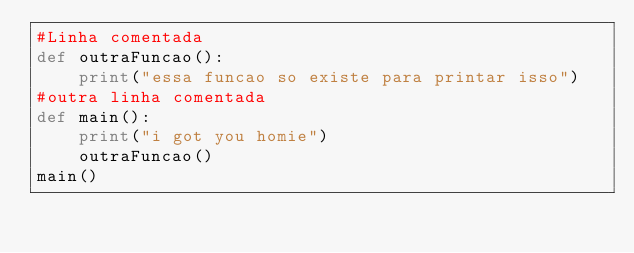Convert code to text. <code><loc_0><loc_0><loc_500><loc_500><_Python_>#Linha comentada
def outraFuncao():
    print("essa funcao so existe para printar isso")
#outra linha comentada
def main():
    print("i got you homie")
    outraFuncao()
main()
</code> 